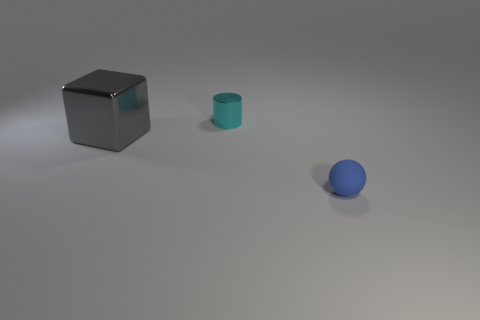Add 3 big gray cubes. How many objects exist? 6 Subtract all blocks. How many objects are left? 2 Subtract 0 cyan spheres. How many objects are left? 3 Subtract all large shiny blocks. Subtract all small cyan shiny cylinders. How many objects are left? 1 Add 3 blue matte things. How many blue matte things are left? 4 Add 2 yellow metal cylinders. How many yellow metal cylinders exist? 2 